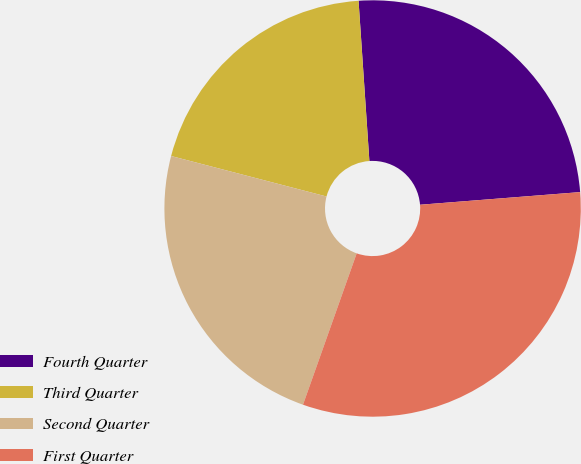Convert chart. <chart><loc_0><loc_0><loc_500><loc_500><pie_chart><fcel>Fourth Quarter<fcel>Third Quarter<fcel>Second Quarter<fcel>First Quarter<nl><fcel>24.82%<fcel>19.87%<fcel>23.63%<fcel>31.68%<nl></chart> 